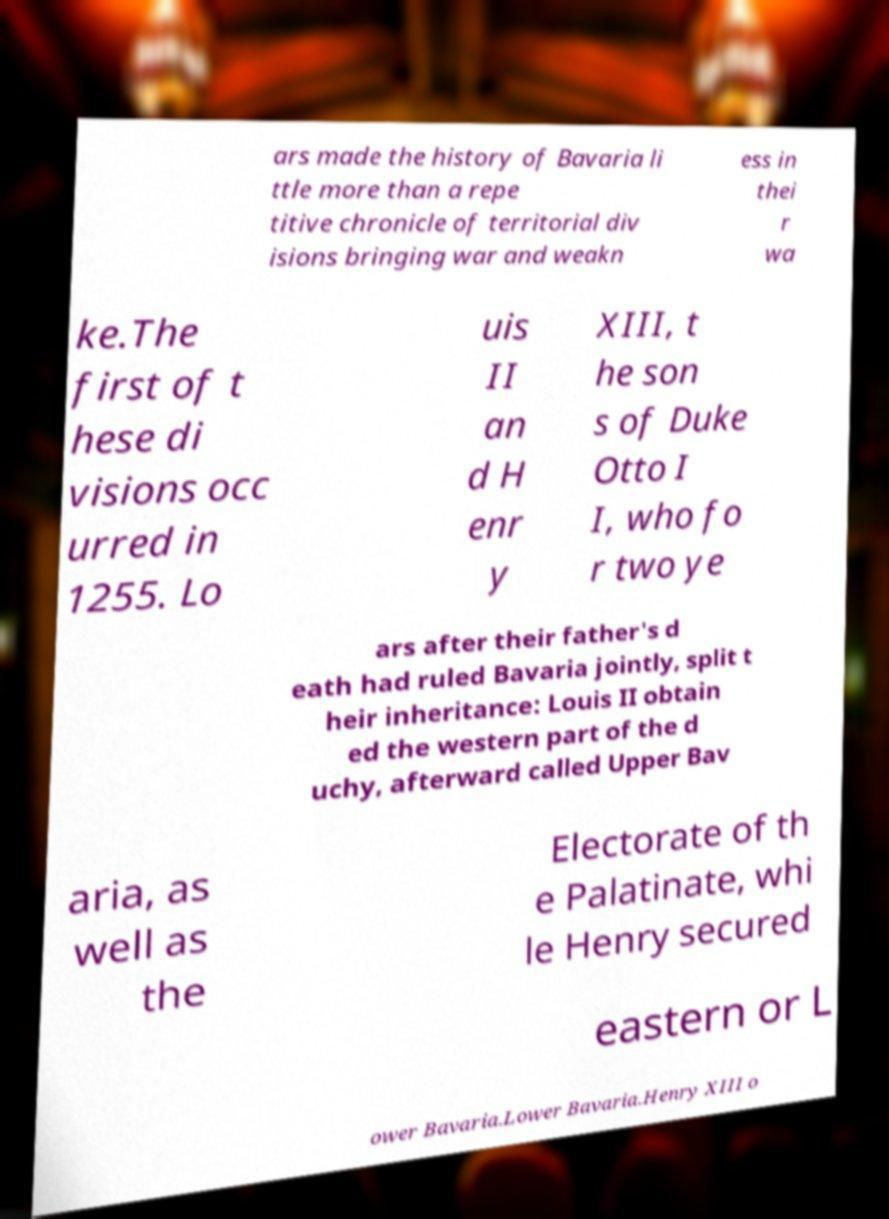I need the written content from this picture converted into text. Can you do that? ars made the history of Bavaria li ttle more than a repe titive chronicle of territorial div isions bringing war and weakn ess in thei r wa ke.The first of t hese di visions occ urred in 1255. Lo uis II an d H enr y XIII, t he son s of Duke Otto I I, who fo r two ye ars after their father's d eath had ruled Bavaria jointly, split t heir inheritance: Louis II obtain ed the western part of the d uchy, afterward called Upper Bav aria, as well as the Electorate of th e Palatinate, whi le Henry secured eastern or L ower Bavaria.Lower Bavaria.Henry XIII o 